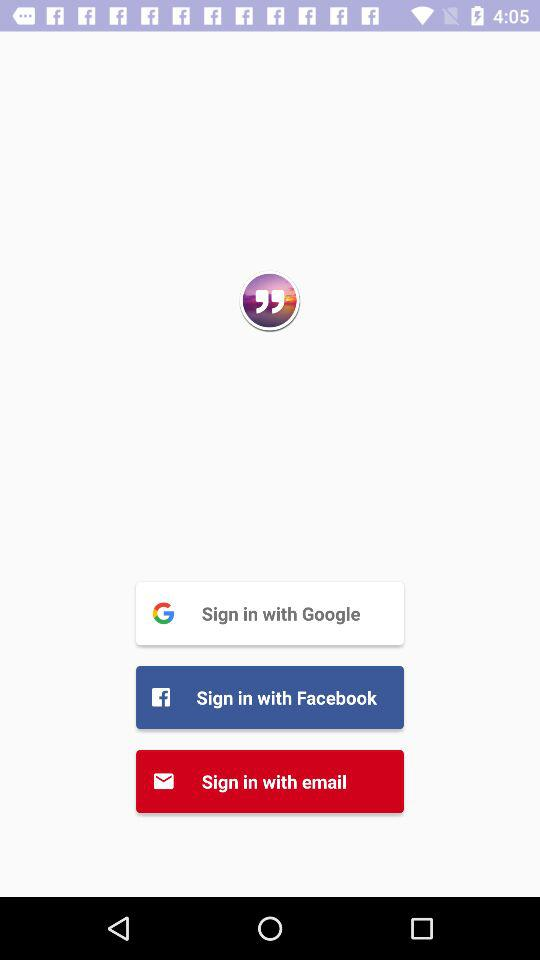How many sign in methods are there?
Answer the question using a single word or phrase. 3 